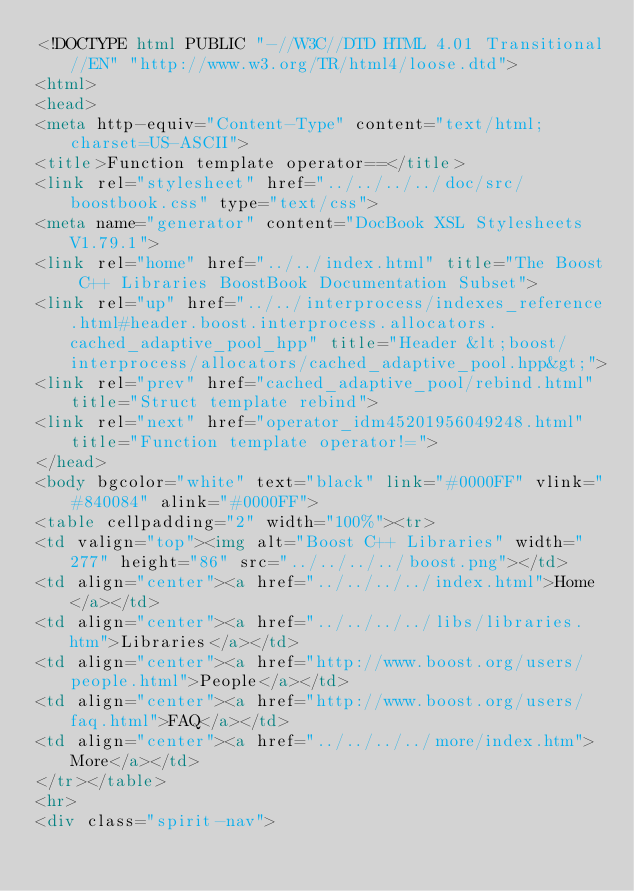<code> <loc_0><loc_0><loc_500><loc_500><_HTML_><!DOCTYPE html PUBLIC "-//W3C//DTD HTML 4.01 Transitional//EN" "http://www.w3.org/TR/html4/loose.dtd">
<html>
<head>
<meta http-equiv="Content-Type" content="text/html; charset=US-ASCII">
<title>Function template operator==</title>
<link rel="stylesheet" href="../../../../doc/src/boostbook.css" type="text/css">
<meta name="generator" content="DocBook XSL Stylesheets V1.79.1">
<link rel="home" href="../../index.html" title="The Boost C++ Libraries BoostBook Documentation Subset">
<link rel="up" href="../../interprocess/indexes_reference.html#header.boost.interprocess.allocators.cached_adaptive_pool_hpp" title="Header &lt;boost/interprocess/allocators/cached_adaptive_pool.hpp&gt;">
<link rel="prev" href="cached_adaptive_pool/rebind.html" title="Struct template rebind">
<link rel="next" href="operator_idm45201956049248.html" title="Function template operator!=">
</head>
<body bgcolor="white" text="black" link="#0000FF" vlink="#840084" alink="#0000FF">
<table cellpadding="2" width="100%"><tr>
<td valign="top"><img alt="Boost C++ Libraries" width="277" height="86" src="../../../../boost.png"></td>
<td align="center"><a href="../../../../index.html">Home</a></td>
<td align="center"><a href="../../../../libs/libraries.htm">Libraries</a></td>
<td align="center"><a href="http://www.boost.org/users/people.html">People</a></td>
<td align="center"><a href="http://www.boost.org/users/faq.html">FAQ</a></td>
<td align="center"><a href="../../../../more/index.htm">More</a></td>
</tr></table>
<hr>
<div class="spirit-nav"></code> 